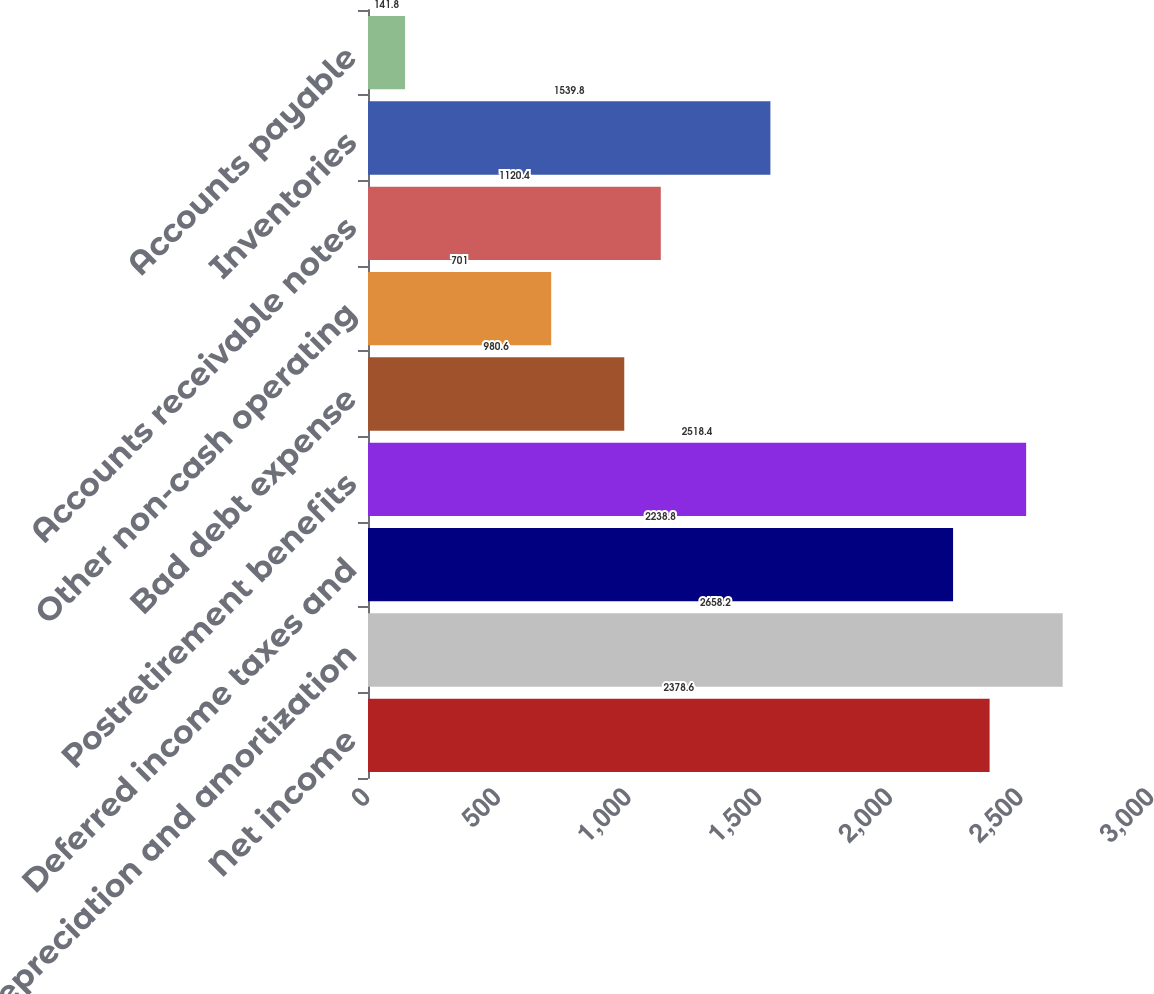Convert chart to OTSL. <chart><loc_0><loc_0><loc_500><loc_500><bar_chart><fcel>Net income<fcel>Depreciation and amortization<fcel>Deferred income taxes and<fcel>Postretirement benefits<fcel>Bad debt expense<fcel>Other non-cash operating<fcel>Accounts receivable notes<fcel>Inventories<fcel>Accounts payable<nl><fcel>2378.6<fcel>2658.2<fcel>2238.8<fcel>2518.4<fcel>980.6<fcel>701<fcel>1120.4<fcel>1539.8<fcel>141.8<nl></chart> 